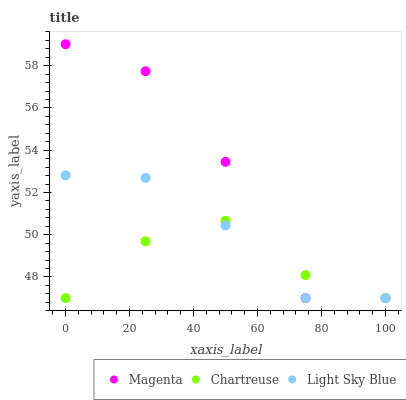Does Chartreuse have the minimum area under the curve?
Answer yes or no. Yes. Does Magenta have the maximum area under the curve?
Answer yes or no. Yes. Does Light Sky Blue have the minimum area under the curve?
Answer yes or no. No. Does Light Sky Blue have the maximum area under the curve?
Answer yes or no. No. Is Chartreuse the smoothest?
Answer yes or no. Yes. Is Magenta the roughest?
Answer yes or no. Yes. Is Light Sky Blue the smoothest?
Answer yes or no. No. Is Light Sky Blue the roughest?
Answer yes or no. No. Does Magenta have the lowest value?
Answer yes or no. Yes. Does Magenta have the highest value?
Answer yes or no. Yes. Does Light Sky Blue have the highest value?
Answer yes or no. No. Does Magenta intersect Chartreuse?
Answer yes or no. Yes. Is Magenta less than Chartreuse?
Answer yes or no. No. Is Magenta greater than Chartreuse?
Answer yes or no. No. 